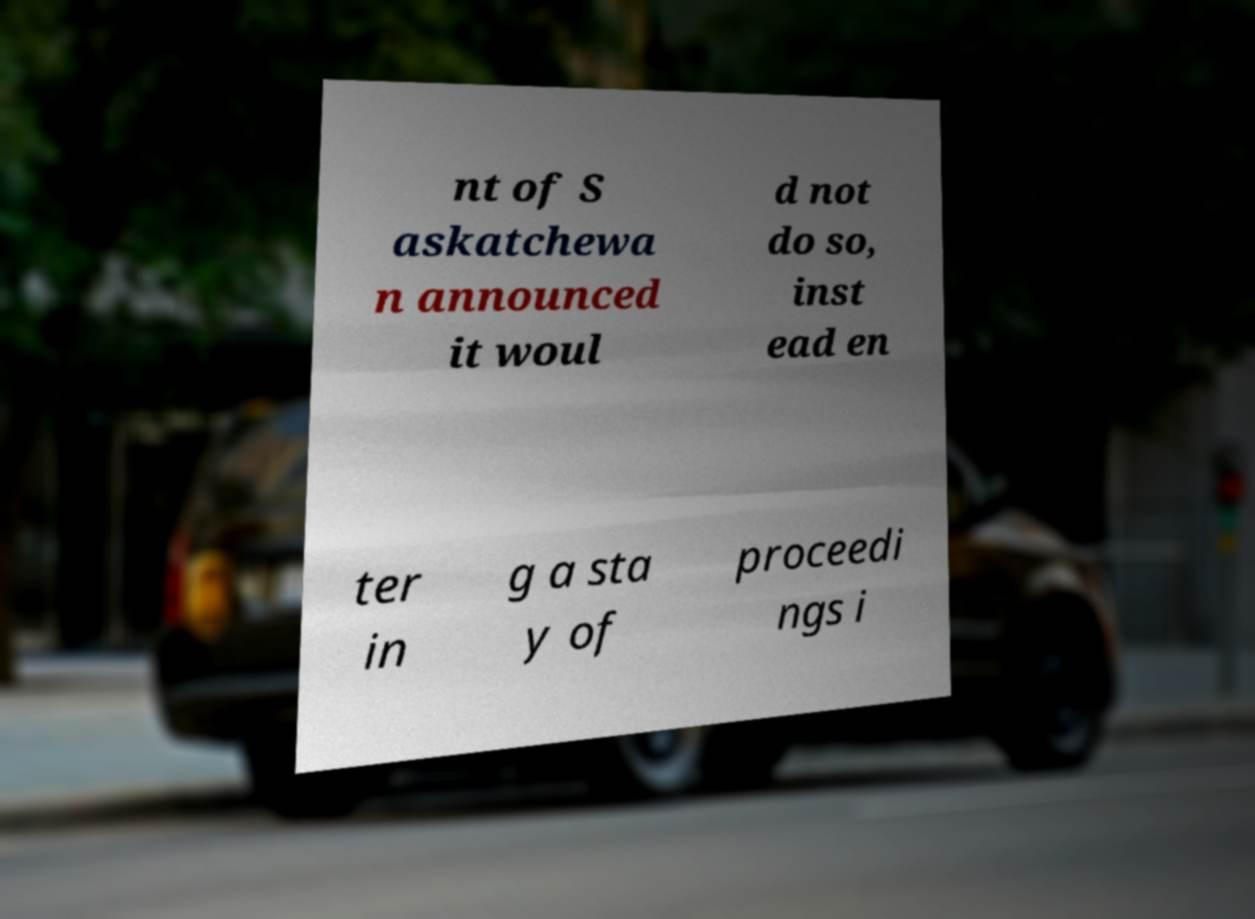Could you assist in decoding the text presented in this image and type it out clearly? nt of S askatchewa n announced it woul d not do so, inst ead en ter in g a sta y of proceedi ngs i 